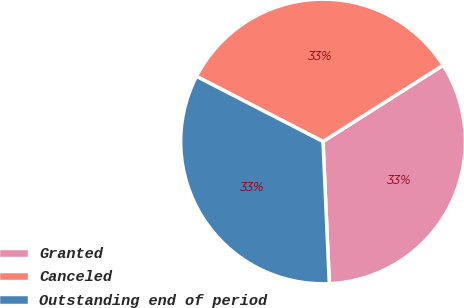<chart> <loc_0><loc_0><loc_500><loc_500><pie_chart><fcel>Granted<fcel>Canceled<fcel>Outstanding end of period<nl><fcel>33.29%<fcel>33.43%<fcel>33.27%<nl></chart> 